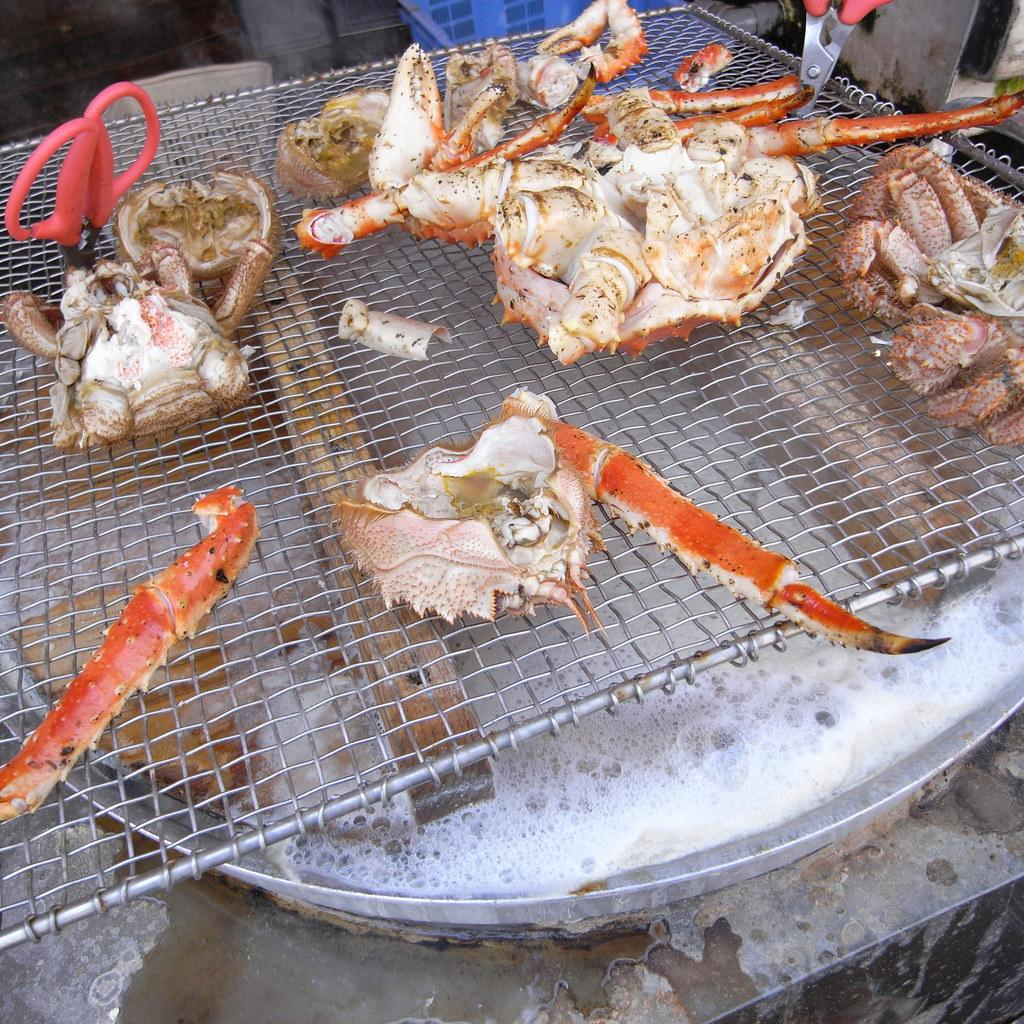What type of food is being prepared on the grill plate in the image? There are pieces of crab on a grill plate in the image. What is the liquid substance in the bowl in the image? There is water in a bowl in the image. What tool is present in the image? Scissors are present in the image. What type of plant is growing in the wilderness in the image? There is no plant or wilderness present in the image. How many volleyballs are visible in the image? There are no volleyballs present in the image. 